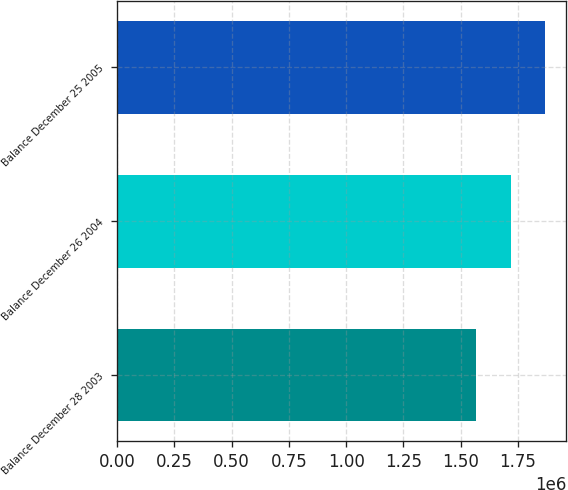<chart> <loc_0><loc_0><loc_500><loc_500><bar_chart><fcel>Balance December 28 2003<fcel>Balance December 26 2004<fcel>Balance December 25 2005<nl><fcel>1.56769e+06<fcel>1.72121e+06<fcel>1.86901e+06<nl></chart> 